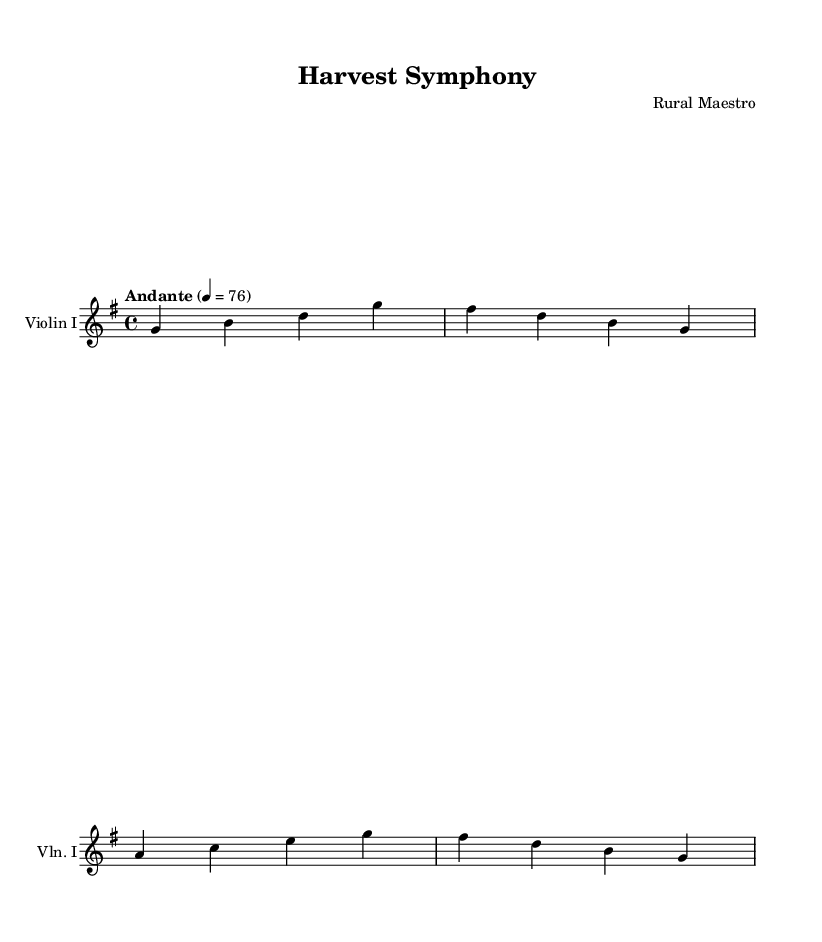What is the key signature of this music? The key signature is defined at the beginning of the score, represented by the sharps or flats next to the clef. In this case, it shows one sharp, indicating G major.
Answer: G major What is the time signature of this music? The time signature is found at the beginning of the score, indicating how many beats are in each measure. It is noted as 4/4, meaning four beats per measure, with a quarter note receiving one beat.
Answer: 4/4 What is the tempo marking of this music? The tempo marking appears above the staff and indicates the speed of the music. Here it states "Andante" which suggests a moderate pace, along with the metronome marking of 76 beats per minute.
Answer: Andante How many measures does the piece contain? To find the number of measures, count the vertical lines that separate the groups of notes within the score. Each vertical line represents a measure. Here, there are four measures listed.
Answer: 4 What is the starting note of Violin I? The first note is indicated by the leftmost note on the staff. In this score, that note is G, which is located on the second line from the bottom of the treble clef staff.
Answer: G What does the term "Andante" indicate for this symphony? "Andante" is an instruction for how to perform the piece, indicating that it should be played at a leisurely pace, not too fast nor too slow. It suggests a reflective and peaceful interpretation.
Answer: Leisurly What emotional theme does this symphony likely represent based on its title? Analyzing the title "Harvest Symphony," it is an indication of celebrating agricultural themes and rural life. The term "harvest" often evokes feelings related to gratitude, abundance, and the cycles of nature.
Answer: Agricultural themes 